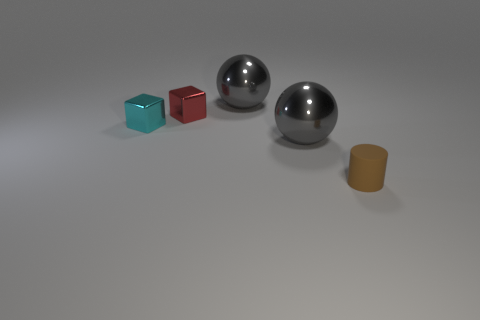What is the shape of the cyan object that is the same material as the red object?
Offer a very short reply. Cube. What is the size of the gray ball left of the gray sphere in front of the tiny red cube?
Your answer should be very brief. Large. What number of cubes are either gray things or tiny red things?
Your answer should be very brief. 1. Do the red block and the ball in front of the small cyan metal object have the same size?
Keep it short and to the point. No. Is the number of big things that are to the left of the small brown cylinder greater than the number of brown metal cylinders?
Offer a terse response. Yes. What size is the cyan object that is made of the same material as the red cube?
Your response must be concise. Small. How many objects are either brown cylinders or metallic objects that are right of the small cyan metallic object?
Ensure brevity in your answer.  4. Is the number of large gray metal objects greater than the number of yellow metal spheres?
Offer a terse response. Yes. Is there a tiny cyan block that has the same material as the cyan thing?
Keep it short and to the point. No. What is the shape of the thing that is both in front of the cyan cube and behind the brown matte thing?
Your answer should be very brief. Sphere. 